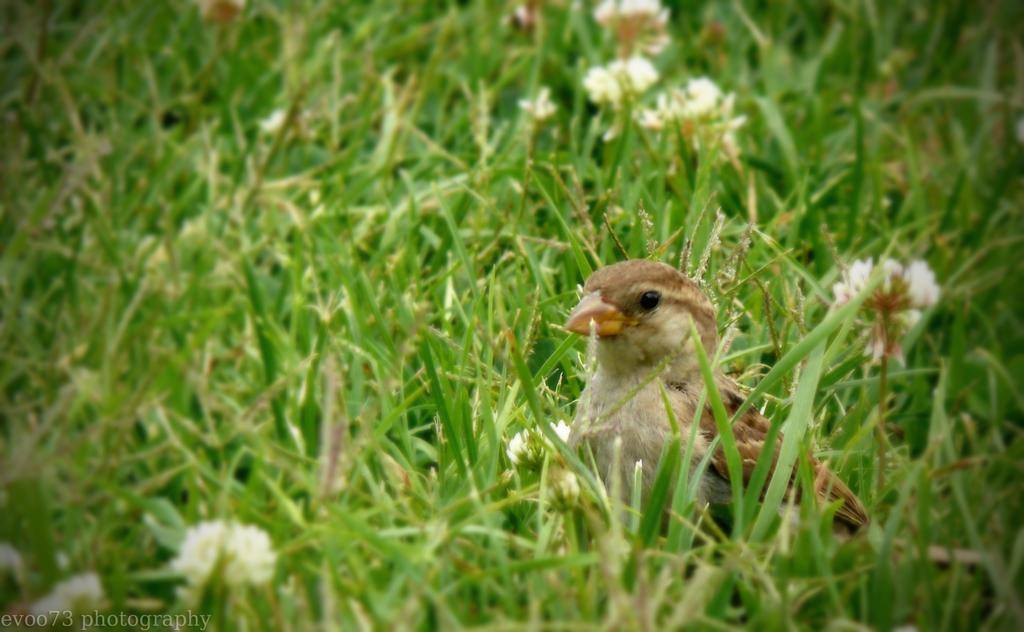What type of animal can be seen in the image? There is a bird in the image. Where is the bird located? The bird is on a path in the image. What other elements can be seen in the image besides the bird? There are plants with flowers in the image. Is there any additional information about the image itself? Yes, there is a watermark on the image. What type of stocking is the bird wearing on its legs in the image? There is no stocking visible on the bird's legs in the image. How many drops of water can be seen falling from the bird's beak in the image? There are no drops of water visible in the image. 